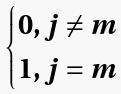Convert formula to latex. <formula><loc_0><loc_0><loc_500><loc_500>\begin{cases} 0 , j \neq m \\ 1 , j = m \end{cases}</formula> 